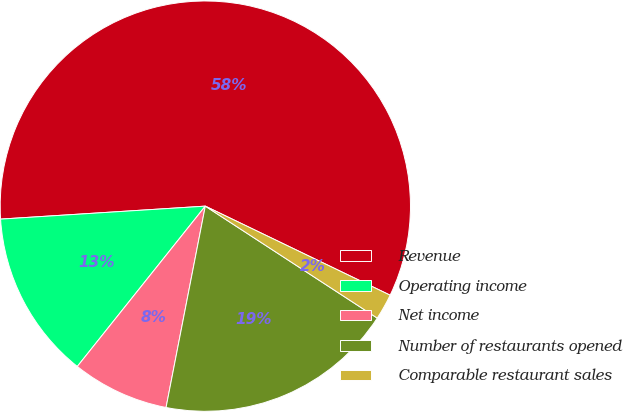<chart> <loc_0><loc_0><loc_500><loc_500><pie_chart><fcel>Revenue<fcel>Operating income<fcel>Net income<fcel>Number of restaurants opened<fcel>Comparable restaurant sales<nl><fcel>58.16%<fcel>13.27%<fcel>7.66%<fcel>18.88%<fcel>2.04%<nl></chart> 